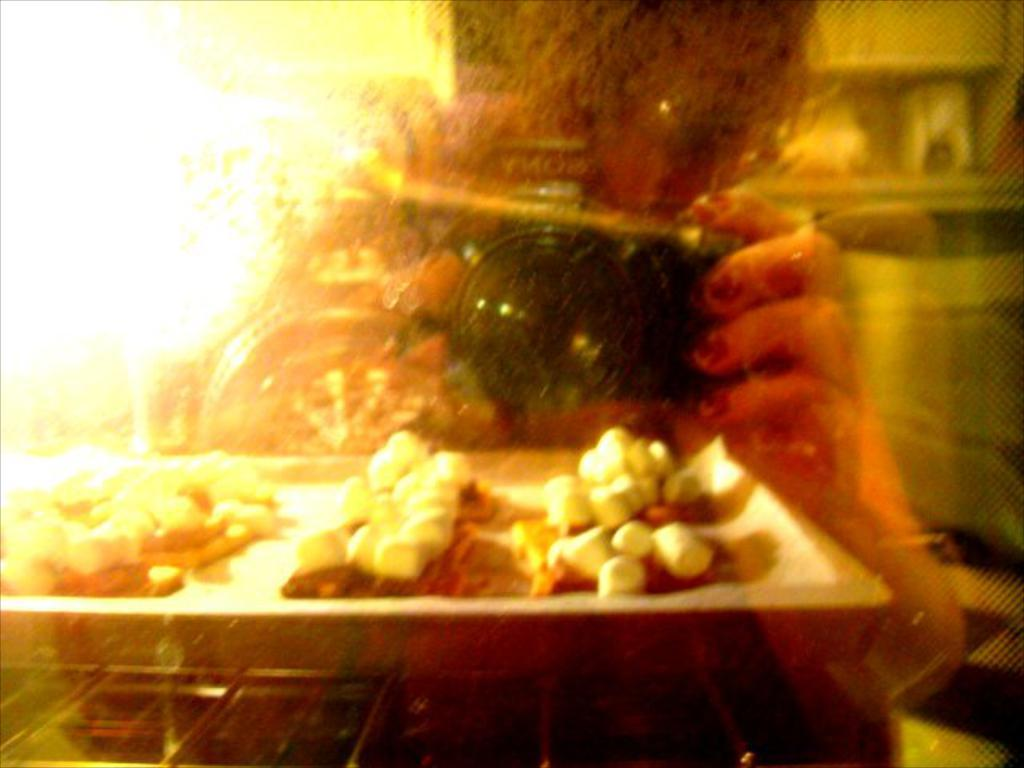What object is visible in the image that is typically used for drinking? There is a glass in the image. What can be seen on the tray in the image? There is a tray with food items in the image. What is the person in the image doing with their hand? A person's hand is holding a camera in the image. How would you describe the background of the image? The background of the image is blurred. What type of support can be seen in the image? There is no support visible in the image. What is the person in the image laughing at? The person in the image is not laughing, as there is no indication of laughter in the image. 